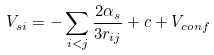<formula> <loc_0><loc_0><loc_500><loc_500>V _ { s i } = - \sum _ { i < j } { \frac { 2 \alpha _ { s } } { 3 r _ { i j } } } + c + V _ { c o n f }</formula> 